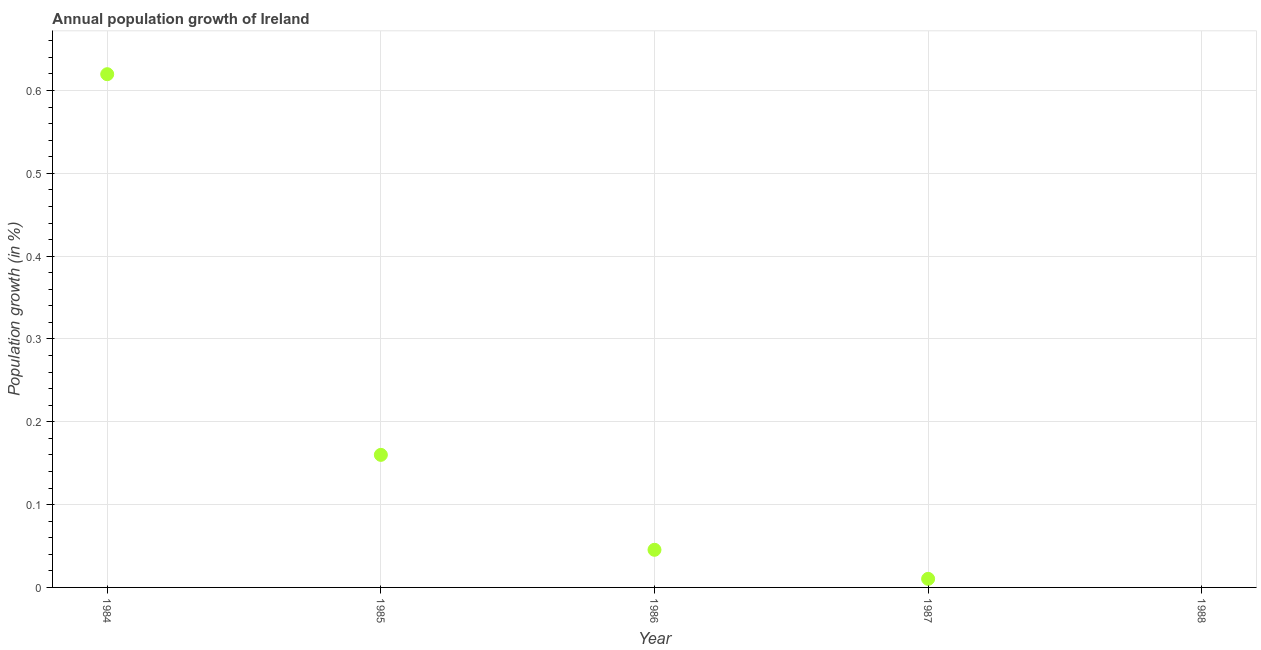What is the population growth in 1984?
Offer a very short reply. 0.62. Across all years, what is the maximum population growth?
Make the answer very short. 0.62. Across all years, what is the minimum population growth?
Your answer should be compact. 0. In which year was the population growth maximum?
Your answer should be very brief. 1984. What is the sum of the population growth?
Your answer should be very brief. 0.84. What is the difference between the population growth in 1984 and 1987?
Your response must be concise. 0.61. What is the average population growth per year?
Your answer should be compact. 0.17. What is the median population growth?
Offer a very short reply. 0.05. What is the ratio of the population growth in 1984 to that in 1987?
Give a very brief answer. 59.77. What is the difference between the highest and the second highest population growth?
Your answer should be very brief. 0.46. Is the sum of the population growth in 1984 and 1987 greater than the maximum population growth across all years?
Your answer should be very brief. Yes. What is the difference between the highest and the lowest population growth?
Your answer should be compact. 0.62. In how many years, is the population growth greater than the average population growth taken over all years?
Offer a terse response. 1. How many dotlines are there?
Your answer should be very brief. 1. How many years are there in the graph?
Offer a terse response. 5. Are the values on the major ticks of Y-axis written in scientific E-notation?
Provide a succinct answer. No. Does the graph contain any zero values?
Ensure brevity in your answer.  Yes. What is the title of the graph?
Your answer should be compact. Annual population growth of Ireland. What is the label or title of the Y-axis?
Your answer should be very brief. Population growth (in %). What is the Population growth (in %) in 1984?
Your response must be concise. 0.62. What is the Population growth (in %) in 1985?
Your response must be concise. 0.16. What is the Population growth (in %) in 1986?
Offer a very short reply. 0.05. What is the Population growth (in %) in 1987?
Provide a succinct answer. 0.01. What is the Population growth (in %) in 1988?
Give a very brief answer. 0. What is the difference between the Population growth (in %) in 1984 and 1985?
Give a very brief answer. 0.46. What is the difference between the Population growth (in %) in 1984 and 1986?
Ensure brevity in your answer.  0.57. What is the difference between the Population growth (in %) in 1984 and 1987?
Make the answer very short. 0.61. What is the difference between the Population growth (in %) in 1985 and 1986?
Give a very brief answer. 0.11. What is the difference between the Population growth (in %) in 1985 and 1987?
Ensure brevity in your answer.  0.15. What is the difference between the Population growth (in %) in 1986 and 1987?
Your answer should be very brief. 0.04. What is the ratio of the Population growth (in %) in 1984 to that in 1985?
Ensure brevity in your answer.  3.87. What is the ratio of the Population growth (in %) in 1984 to that in 1986?
Keep it short and to the point. 13.64. What is the ratio of the Population growth (in %) in 1984 to that in 1987?
Make the answer very short. 59.77. What is the ratio of the Population growth (in %) in 1985 to that in 1986?
Provide a succinct answer. 3.52. What is the ratio of the Population growth (in %) in 1985 to that in 1987?
Your response must be concise. 15.44. What is the ratio of the Population growth (in %) in 1986 to that in 1987?
Your answer should be very brief. 4.38. 